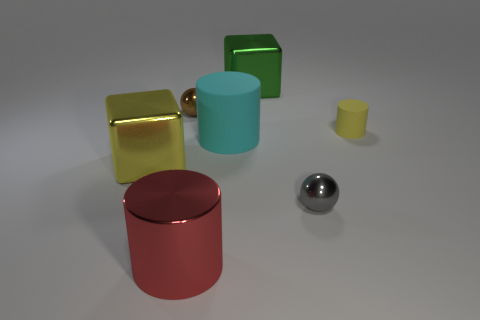Add 3 gray things. How many objects exist? 10 Subtract all tiny yellow rubber cylinders. How many cylinders are left? 2 Subtract all yellow cubes. How many cubes are left? 1 Subtract all balls. How many objects are left? 5 Subtract all big green shiny blocks. Subtract all yellow rubber cylinders. How many objects are left? 5 Add 5 large metallic objects. How many large metallic objects are left? 8 Add 1 small rubber cylinders. How many small rubber cylinders exist? 2 Subtract 0 red blocks. How many objects are left? 7 Subtract 2 balls. How many balls are left? 0 Subtract all red spheres. Subtract all red cylinders. How many spheres are left? 2 